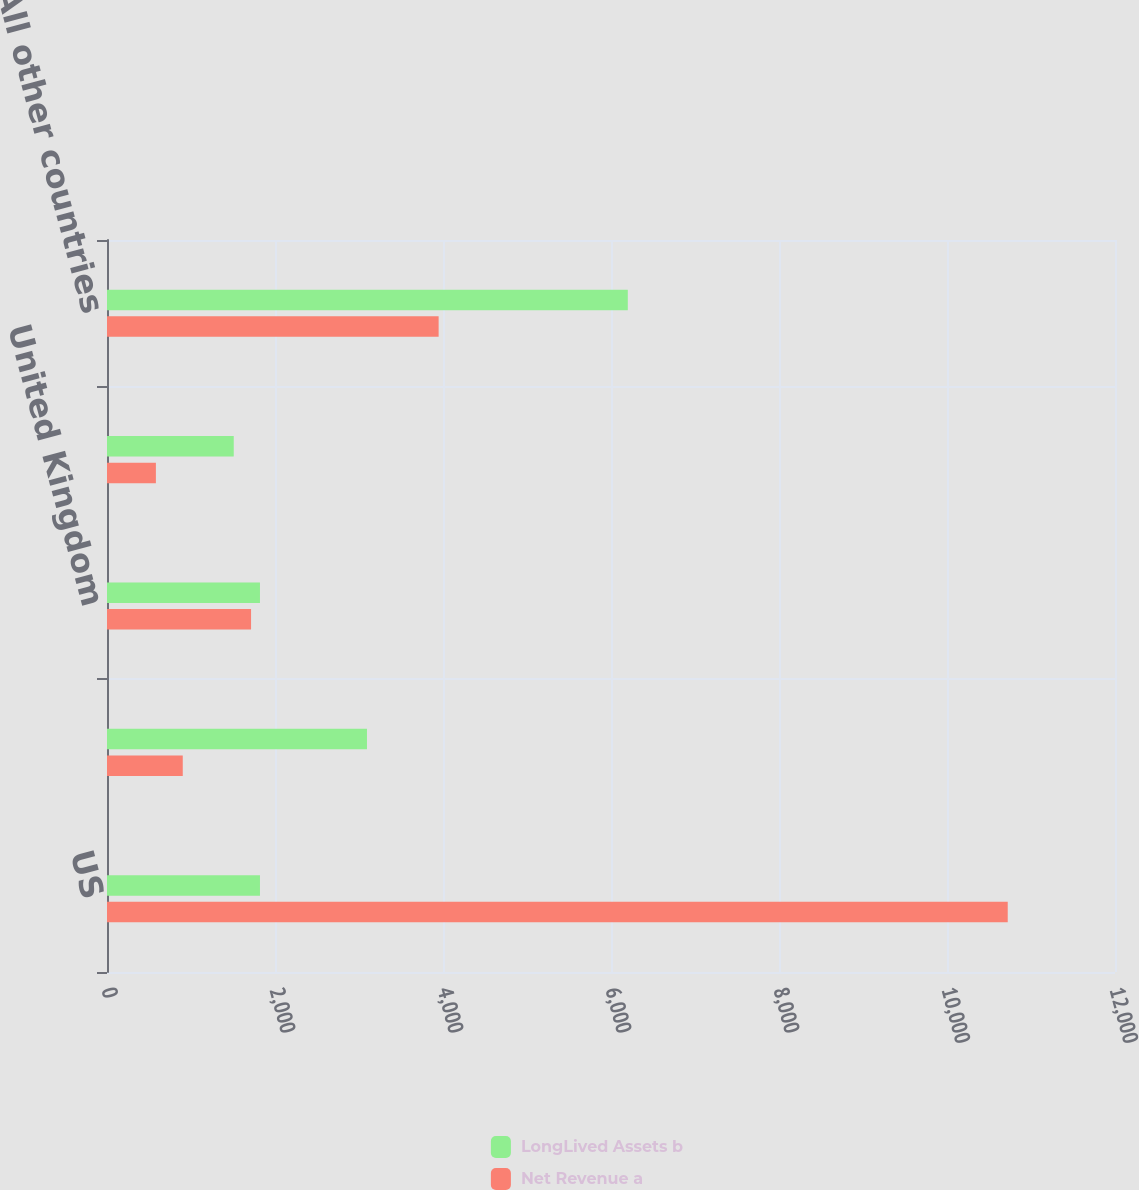<chart> <loc_0><loc_0><loc_500><loc_500><stacked_bar_chart><ecel><fcel>US<fcel>Mexico<fcel>United Kingdom<fcel>Canada<fcel>All other countries<nl><fcel>LongLived Assets b<fcel>1821<fcel>3095<fcel>1821<fcel>1509<fcel>6200<nl><fcel>Net Revenue a<fcel>10723<fcel>902<fcel>1715<fcel>582<fcel>3948<nl></chart> 